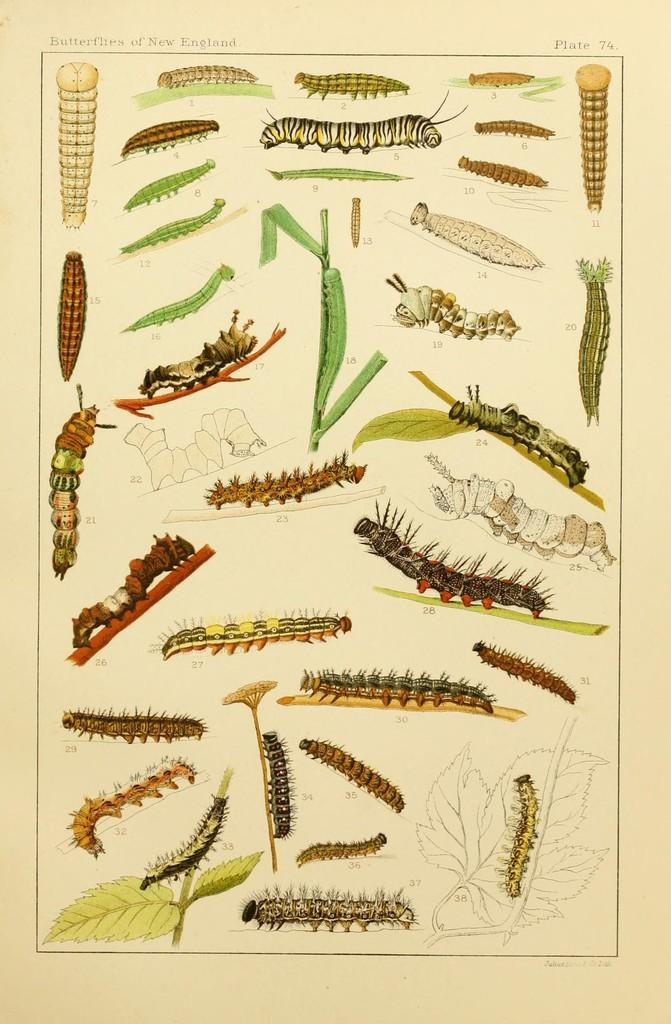What is the main subject of the paper in the image? The paper contains images of different types of insects. Is there any text on the paper? Yes, there is text on the paper. Can you identify any specific information on the paper? There is a number on the paper. What actor is performing in the image? There is no actor present in the image; it features a paper with images of insects and text. What type of material is the fireman using to extinguish the fire in the image? There is no fireman or fire present in the image; it features a paper with images of insects and text. 